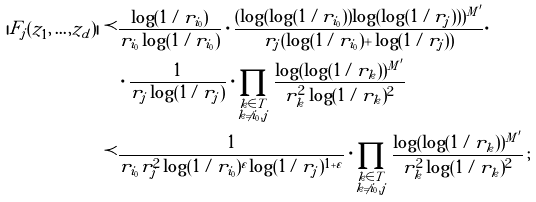<formula> <loc_0><loc_0><loc_500><loc_500>| F _ { j } ( z _ { 1 } , \dots , z _ { d } ) | \prec & \frac { \log ( 1 / r _ { i _ { 0 } } ) } { r _ { i _ { 0 } } \log ( 1 / r _ { i _ { 0 } } ) } \cdot \frac { ( \log ( \log ( 1 / r _ { i _ { 0 } } ) ) \log ( \log ( 1 / r _ { j } ) ) ) ^ { M ^ { \prime } } } { r _ { j } ( \log ( 1 / r _ { i _ { 0 } } ) + \log ( 1 / r _ { j } ) ) } \cdot \\ & \cdot \frac { 1 } { r _ { j } \log ( 1 / r _ { j } ) } \cdot \prod _ { \substack { k \in T \\ k \neq i _ { 0 } , j } } \frac { \log ( \log ( 1 / r _ { k } ) ) ^ { M ^ { \prime } } } { r _ { k } ^ { 2 } \log ( 1 / r _ { k } ) ^ { 2 } } \\ \prec & \frac { 1 } { r _ { i _ { 0 } } r _ { j } ^ { 2 } \log ( 1 / r _ { i _ { 0 } } ) ^ { \varepsilon } \log ( 1 / r _ { j } ) ^ { 1 + \varepsilon } } \cdot \prod _ { \substack { k \in T \\ k \neq i _ { 0 } , j } } \frac { \log ( \log ( 1 / r _ { k } ) ) ^ { M ^ { \prime } } } { r _ { k } ^ { 2 } \log ( 1 / r _ { k } ) ^ { 2 } } \, ;</formula> 